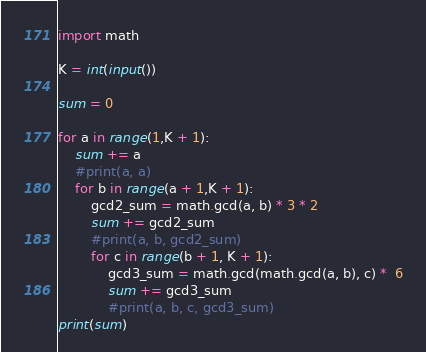Convert code to text. <code><loc_0><loc_0><loc_500><loc_500><_Python_>import math

K = int(input())

sum = 0

for a in range(1,K + 1):
    sum += a
    #print(a, a)
    for b in range(a + 1,K + 1):
        gcd2_sum = math.gcd(a, b) * 3 * 2
        sum += gcd2_sum
        #print(a, b, gcd2_sum)
        for c in range(b + 1, K + 1):
            gcd3_sum = math.gcd(math.gcd(a, b), c) *  6
            sum += gcd3_sum
            #print(a, b, c, gcd3_sum)
print(sum)
</code> 